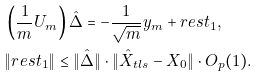Convert formula to latex. <formula><loc_0><loc_0><loc_500><loc_500>& \left ( \frac { 1 } { m } U _ { m } \right ) \hat { \Delta } = - \frac { 1 } { \sqrt { m } } y _ { m } + r e s t _ { 1 } , \\ & \| r e s t _ { 1 } \| \leq \| \hat { \Delta } \| \cdot \| \hat { X } _ { t l s } - X _ { 0 } \| \cdot O _ { p } ( 1 ) .</formula> 